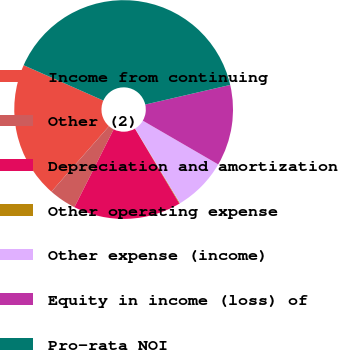Convert chart to OTSL. <chart><loc_0><loc_0><loc_500><loc_500><pie_chart><fcel>Income from continuing<fcel>Other (2)<fcel>Depreciation and amortization<fcel>Other operating expense<fcel>Other expense (income)<fcel>Equity in income (loss) of<fcel>Pro-rata NOI<nl><fcel>20.16%<fcel>4.05%<fcel>15.95%<fcel>0.09%<fcel>8.02%<fcel>11.98%<fcel>39.75%<nl></chart> 